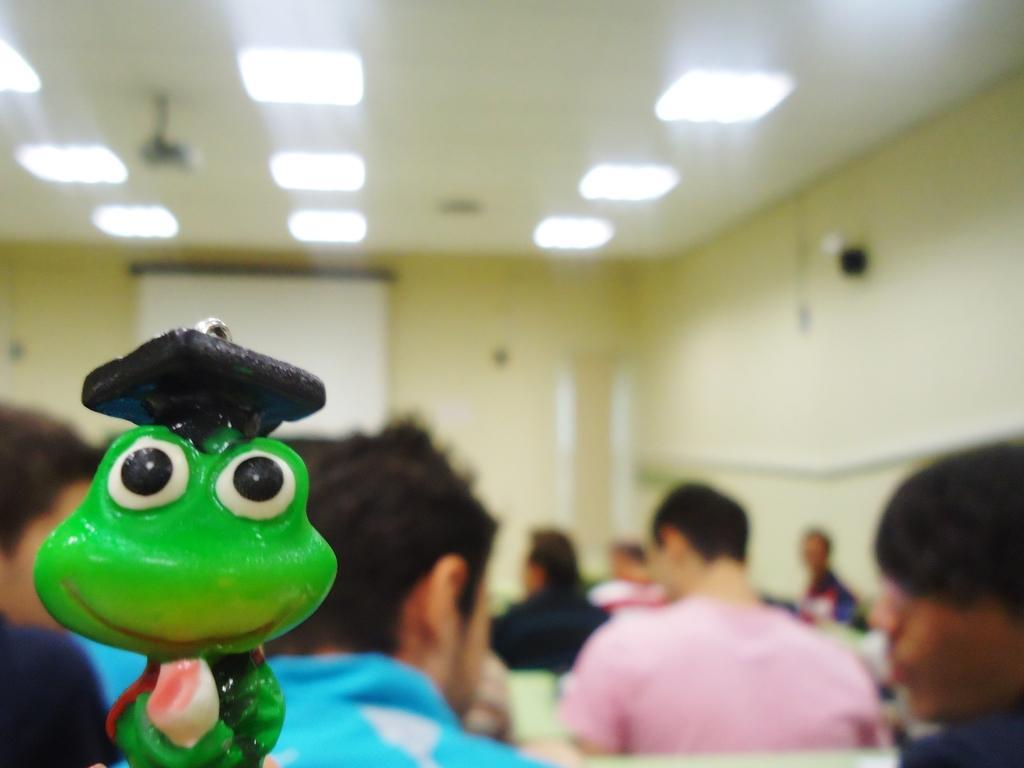Can you describe this image briefly? In this image we can see a green color toy here. The background of the image is slightly blurred, where we can see these people are sitting, a white color board, the wall and lights on the ceiling. 